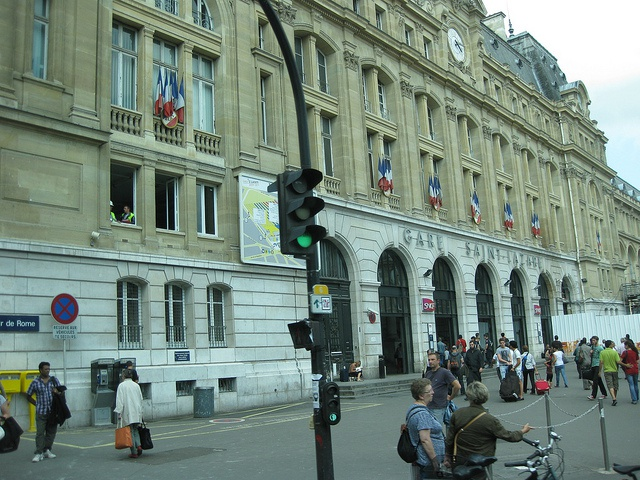Describe the objects in this image and their specific colors. I can see people in gray, black, and darkgreen tones, traffic light in gray, black, teal, darkgray, and darkgreen tones, people in gray, black, and blue tones, bicycle in gray and black tones, and people in gray, black, blue, and navy tones in this image. 